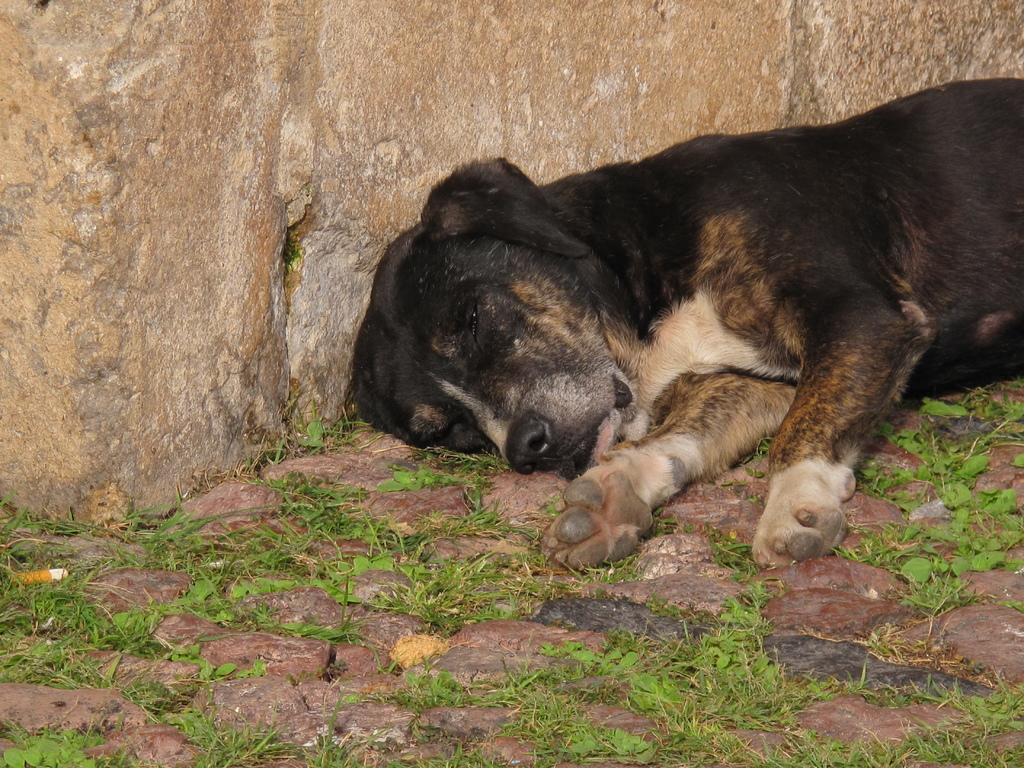What is the main subject in the center of the image? There is a dog in the center of the image. What type of surface is visible at the bottom of the image? There is grass and a walkway at the bottom of the image. What can be seen in the background of the image? There is a wall in the background of the image. What type of fan is visible in the image? There is no fan present in the image. What color is the dog's underwear in the image? Dogs do not wear underwear, and there is no underwear visible in the image. 